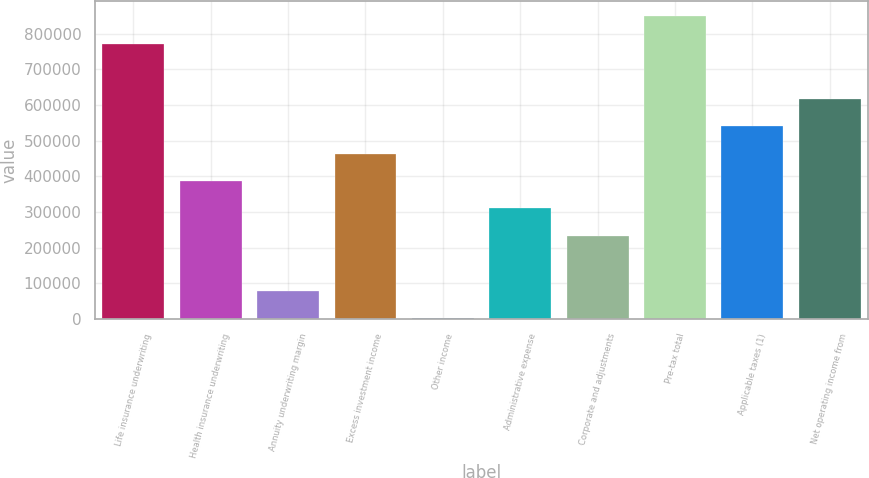Convert chart to OTSL. <chart><loc_0><loc_0><loc_500><loc_500><bar_chart><fcel>Life insurance underwriting<fcel>Health insurance underwriting<fcel>Annuity underwriting margin<fcel>Excess investment income<fcel>Other income<fcel>Administrative expense<fcel>Corporate and adjustments<fcel>Pre-tax total<fcel>Applicable taxes (1)<fcel>Net operating income from<nl><fcel>771644<fcel>386999<fcel>79283<fcel>463928<fcel>2354<fcel>310070<fcel>233141<fcel>848573<fcel>540857<fcel>617786<nl></chart> 